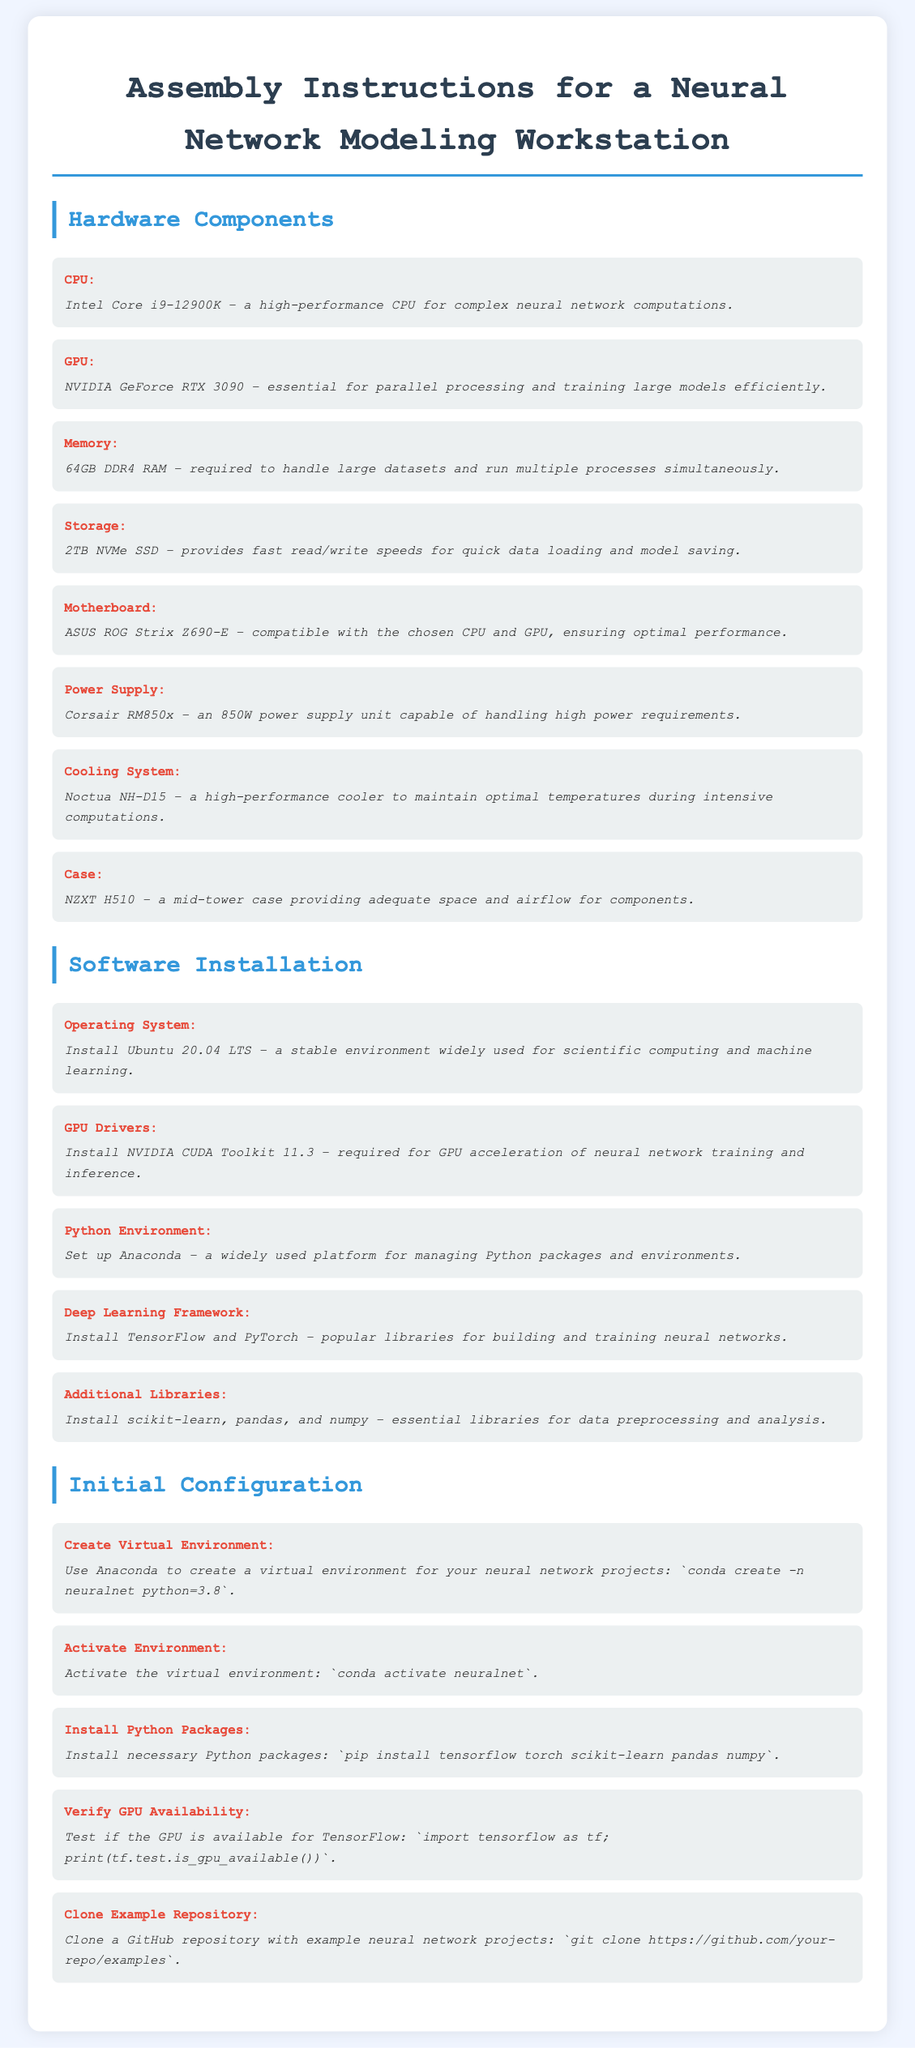What is the CPU model recommended? The document lists Intel Core i9-12900K as the recommended CPU model for the workstation.
Answer: Intel Core i9-12900K What is the required memory size? The document specifies that 64GB DDR4 RAM is required for handling large datasets.
Answer: 64GB DDR4 RAM Which operating system should be installed? The assembly instructions indicate installing Ubuntu 20.04 LTS for the workstation.
Answer: Ubuntu 20.04 LTS How many terabytes of storage are recommended? The document mentions a 2TB NVMe SSD as the necessary storage size for quick data operations.
Answer: 2TB NVMe SSD What is the purpose of the NVIDIA CUDA Toolkit? The instruction states that it is required for GPU acceleration of neural network training and inference.
Answer: GPU acceleration What should be the first step in software installation? The first step in software installation is to install the operating system, which is mentioned as Ubuntu 20.04 LTS.
Answer: Install Ubuntu 20.04 LTS How do you verify GPU availability? The document suggests running specific code to check GPU availability in TensorFlow.
Answer: import tensorflow as tf; print(tf.test.is_gpu_available()) What is the command to create a virtual environment? The document provides the command for creating a virtual environment: conda create -n neuralnet python=3.8.
Answer: conda create -n neuralnet python=3.8 What type of case is recommended for the workstation? The assembly instructions recommend using an NZXT H510 case for adequate space and airflow.
Answer: NZXT H510 